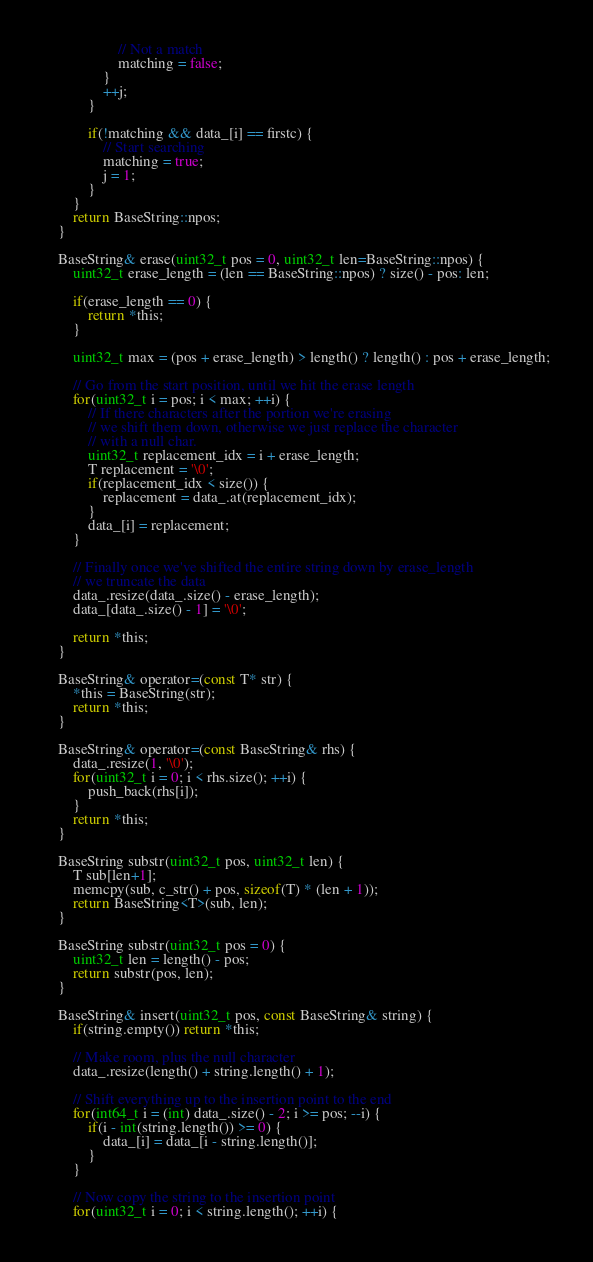<code> <loc_0><loc_0><loc_500><loc_500><_C_>                    // Not a match
                    matching = false;
                }
                ++j;
            }

            if(!matching && data_[i] == firstc) {
                // Start searching
                matching = true;
                j = 1;
            }
        }
        return BaseString::npos;
    }

    BaseString& erase(uint32_t pos = 0, uint32_t len=BaseString::npos) {
        uint32_t erase_length = (len == BaseString::npos) ? size() - pos: len;

        if(erase_length == 0) {
            return *this;
        }

        uint32_t max = (pos + erase_length) > length() ? length() : pos + erase_length;

        // Go from the start position, until we hit the erase length
        for(uint32_t i = pos; i < max; ++i) {
            // If there characters after the portion we're erasing
            // we shift them down, otherwise we just replace the character
            // with a null char.
            uint32_t replacement_idx = i + erase_length;
            T replacement = '\0';
            if(replacement_idx < size()) {
                replacement = data_.at(replacement_idx);
            }
            data_[i] = replacement;
        }

        // Finally once we've shifted the entire string down by erase_length
        // we truncate the data
        data_.resize(data_.size() - erase_length);
        data_[data_.size() - 1] = '\0';

        return *this;
    }

    BaseString& operator=(const T* str) {
        *this = BaseString(str);
        return *this;
    }

    BaseString& operator=(const BaseString& rhs) {
        data_.resize(1, '\0');
        for(uint32_t i = 0; i < rhs.size(); ++i) {
            push_back(rhs[i]);
        }
        return *this;
    }

    BaseString substr(uint32_t pos, uint32_t len) {
        T sub[len+1];
        memcpy(sub, c_str() + pos, sizeof(T) * (len + 1));
        return BaseString<T>(sub, len);
    }

    BaseString substr(uint32_t pos = 0) {
        uint32_t len = length() - pos;
        return substr(pos, len);
    }

    BaseString& insert(uint32_t pos, const BaseString& string) {
        if(string.empty()) return *this;

        // Make room, plus the null character
        data_.resize(length() + string.length() + 1);

        // Shift everything up to the insertion point to the end
        for(int64_t i = (int) data_.size() - 2; i >= pos; --i) {
            if(i - int(string.length()) >= 0) {
                data_[i] = data_[i - string.length()];
            }
        }

        // Now copy the string to the insertion point
        for(uint32_t i = 0; i < string.length(); ++i) {</code> 